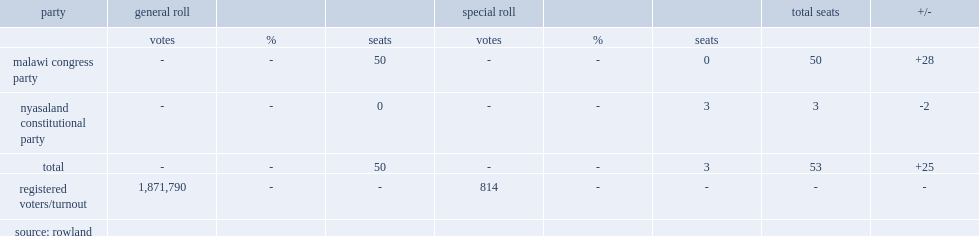How many people registered for the general roll? 1871790.0. How many people registered for the special roll? 814.0. 